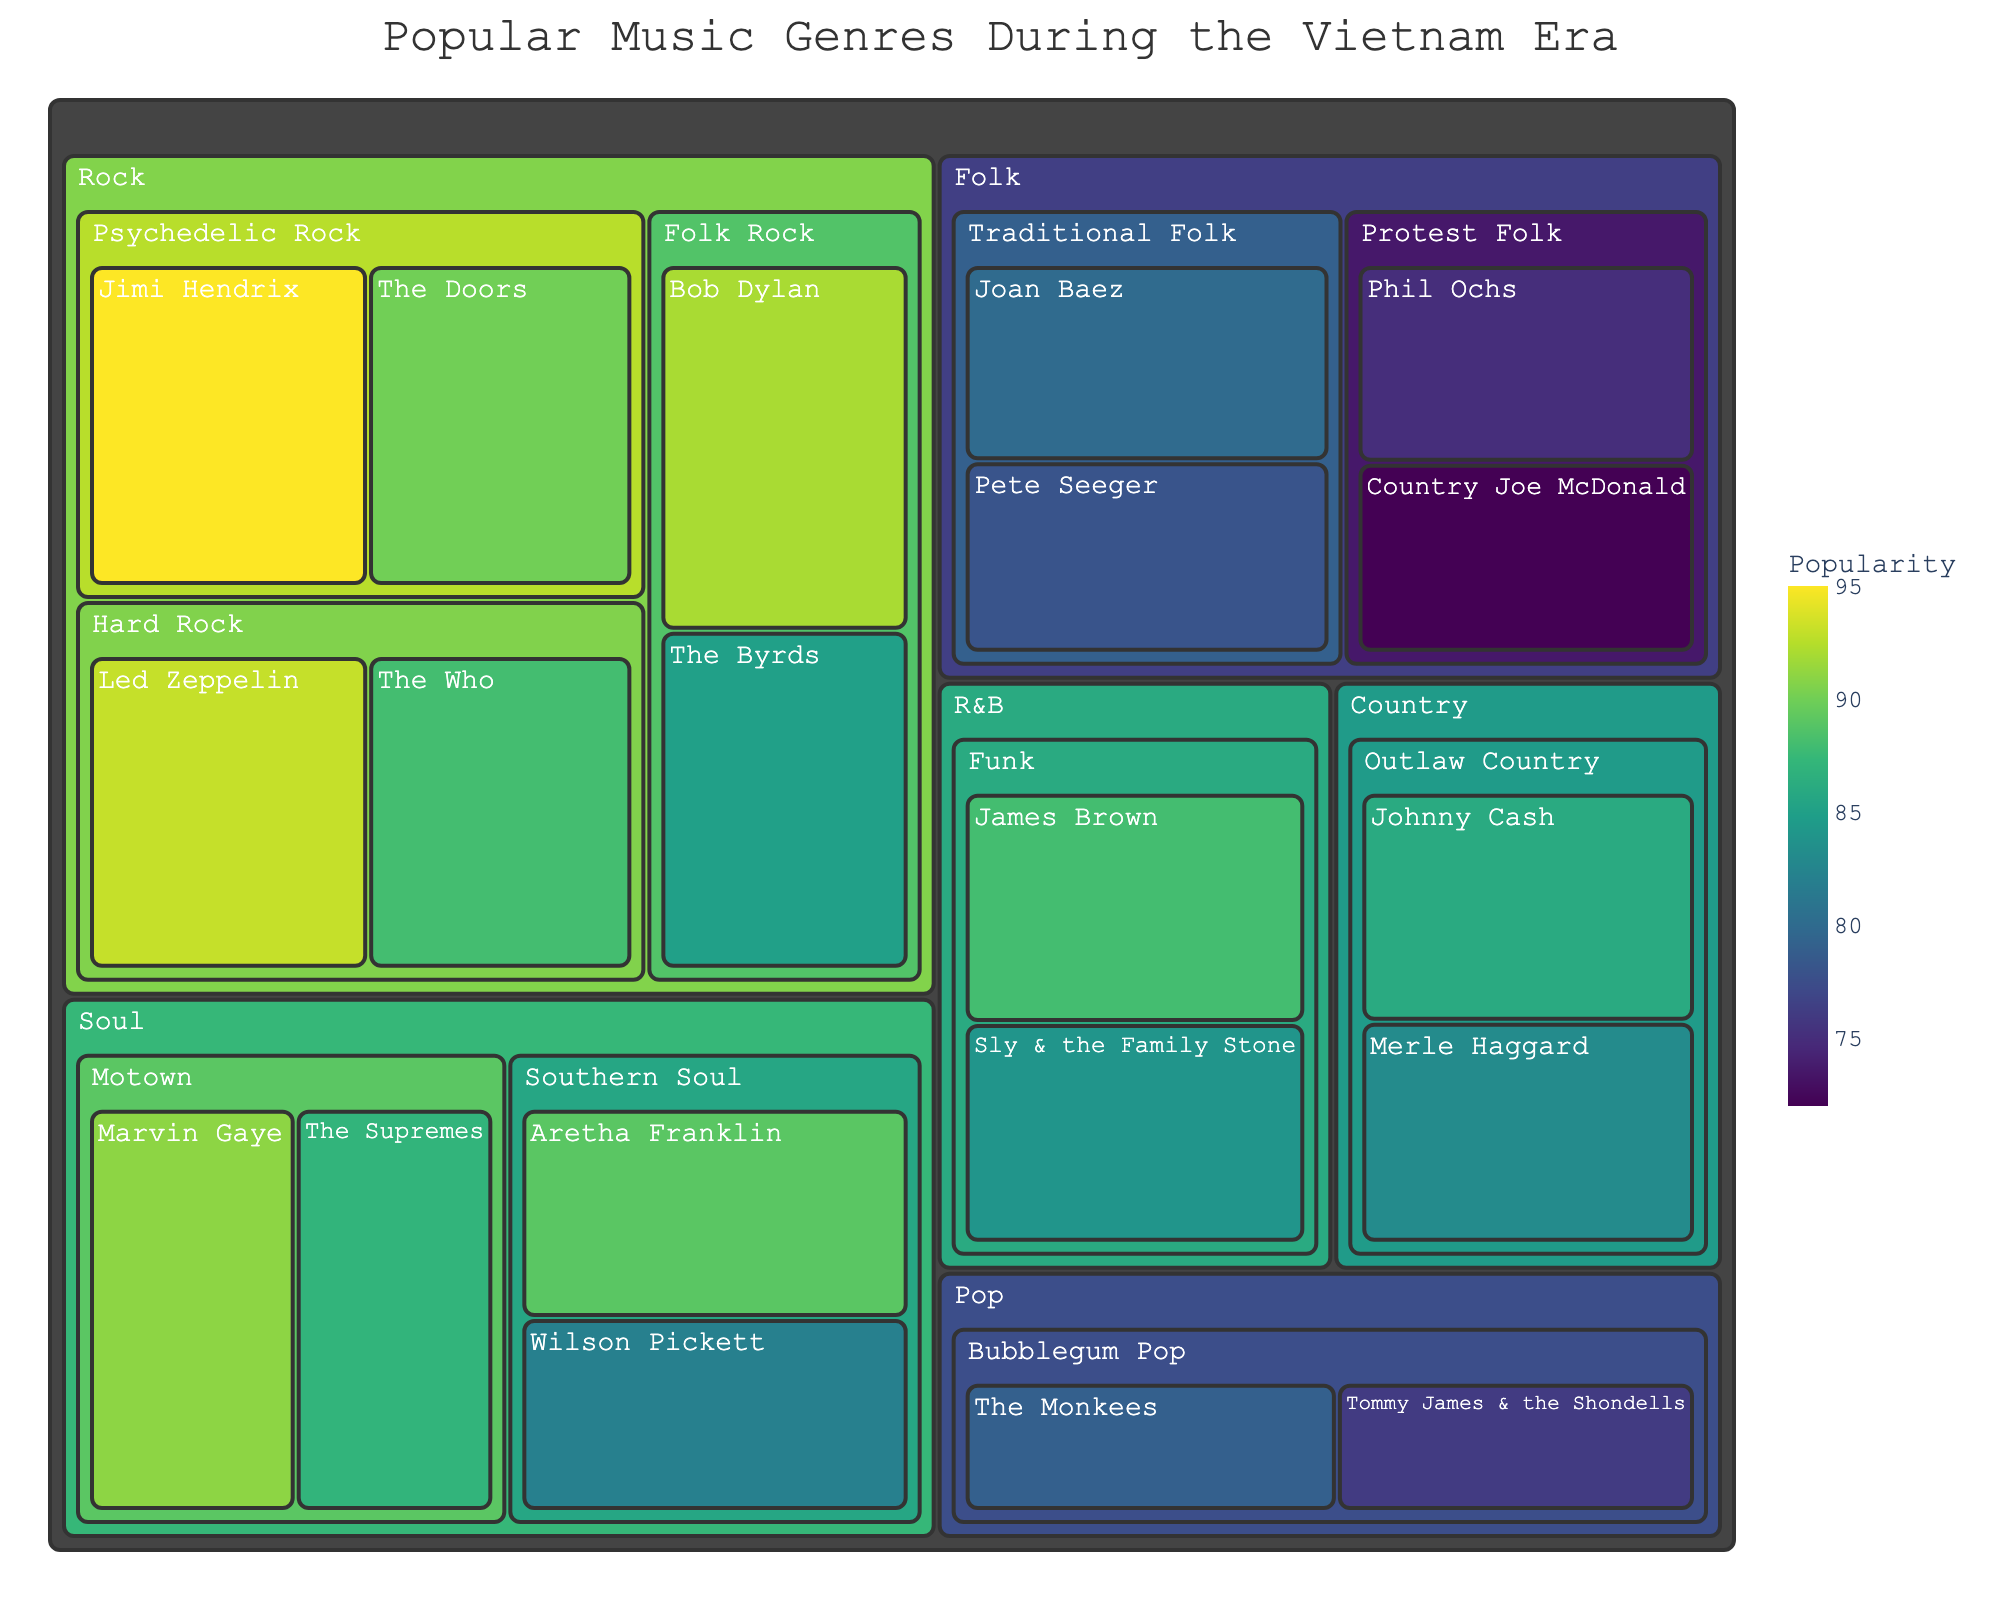What genre has the highest artist popularity? To find the genre with the highest artist popularity, locate the tile with the highest popularity value. Jimi Hendrix (95) under Psychedelic Rock in the Rock genre has the highest popularity. Therefore, the genre is Rock.
Answer: Rock Which artist represents the Traditional Folk subgenre with the highest popularity? Look within the Traditional Folk subgenre. Compare the popularity values of Joan Baez (80) and Pete Seeger (78). Joan Baez has the highest popularity.
Answer: Joan Baez What is the title of the treemap? The title of the treemap is prominently displayed at the top of the figure. The title reads "Popular Music Genres During the Vietnam Era".
Answer: Popular Music Genres During the Vietnam Era How many artists are defined under the Soul genre? Check the Soul genre and count the number of artists displayed. Marvin Gaye, The Supremes, Aretha Franklin, and Wilson Pickett are the four artists under the Soul genre.
Answer: 4 Between the Funk subgenre and the Protest Folk subgenre, which has higher overall artist popularity? Sum the popularity of artists in each subgenre. Funk: James Brown (88) + Sly & the Family Stone (84) = 172. Protest Folk: Phil Ochs (75) + Country Joe McDonald (72) = 147. Funk has higher overall popularity.
Answer: Funk Who is more popular in the Outlaw Country subgenre, Johnny Cash, or Merle Haggard? Compare the popularity values under the Outlaw Country subgenre. Johnny Cash (86) and Merle Haggard (83). Johnny Cash is more popular.
Answer: Johnny Cash Which subgenre within Rock has the highest total popularity? Add the popularity of the artists within each Rock subgenre. Psychedelic Rock: Jimi Hendrix (95) + The Doors (90) = 185. Folk Rock: Bob Dylan (92) + The Byrds (85) = 177. Hard Rock: Led Zeppelin (93) + The Who (88) = 181. Psychedelic Rock has the highest total popularity.
Answer: Psychedelic Rock What is the least popular artist under the Pop genre? Check the popularity of artists under the Pop genre. The Monkees (79) and Tommy James & the Shondells (76). Tommy James & the Shondells is the least popular.
Answer: Tommy James & the Shondells Which genre has a higher average popularity, Country or Folk? Calculate the average popularity for each genre. Country: (Johnny Cash (86) + Merle Haggard (83)) / 2 = 84.5. Folk: (Joan Baez (80) + Pete Seeger (78) + Phil Ochs (75) + Country Joe McDonald (72)) / 4 = 76.25. Country has a higher average popularity.
Answer: Country 